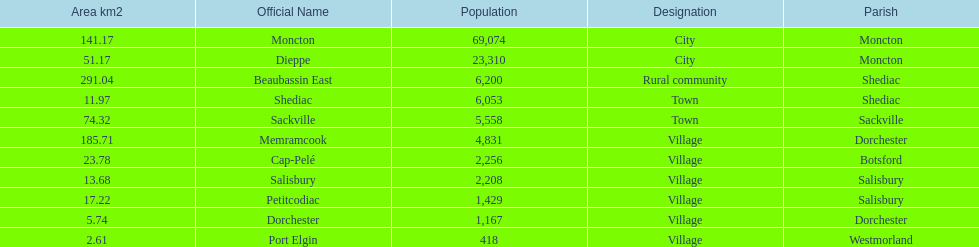Which city has the least area Port Elgin. 